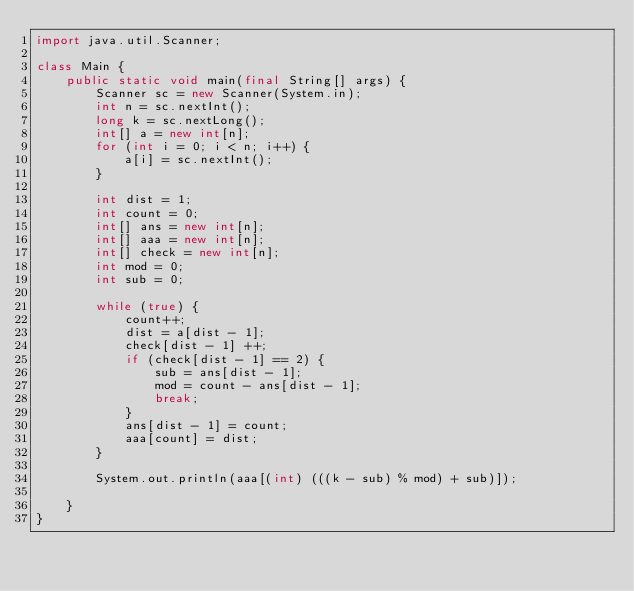Convert code to text. <code><loc_0><loc_0><loc_500><loc_500><_Java_>import java.util.Scanner;

class Main {
    public static void main(final String[] args) {
        Scanner sc = new Scanner(System.in);
        int n = sc.nextInt();
        long k = sc.nextLong();
        int[] a = new int[n];
        for (int i = 0; i < n; i++) {
            a[i] = sc.nextInt();
        }

        int dist = 1;
        int count = 0;
        int[] ans = new int[n];
        int[] aaa = new int[n];
        int[] check = new int[n];
        int mod = 0;
        int sub = 0;

        while (true) {
            count++;
            dist = a[dist - 1];
            check[dist - 1] ++;    
            if (check[dist - 1] == 2) {
                sub = ans[dist - 1];
                mod = count - ans[dist - 1];
                break;
            }
            ans[dist - 1] = count;
            aaa[count] = dist;
        }

        System.out.println(aaa[(int) (((k - sub) % mod) + sub)]);

    }
}
</code> 